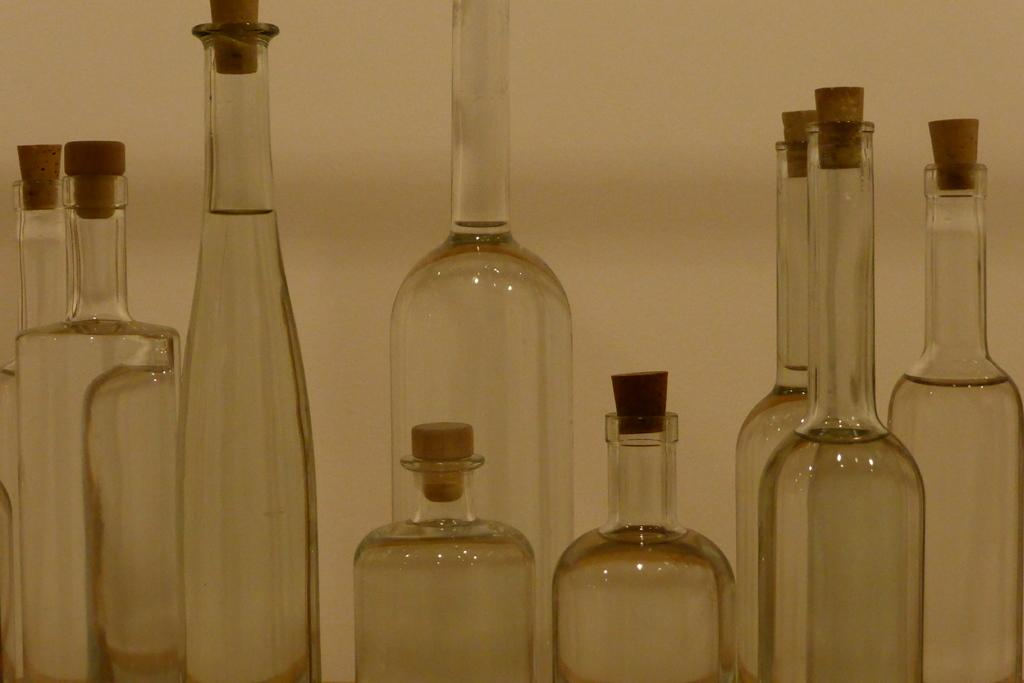What objects are present in the image? There are empty bottles in the image. What feature do the bottles have? The bottles have wooden lids. What can be seen in the background of the image? There is a wall in the background of the image. How many rabbits can be seen hopping on the grass in the image? There are no rabbits or grass present in the image; it only features empty bottles with wooden lids and a wall in the background. 